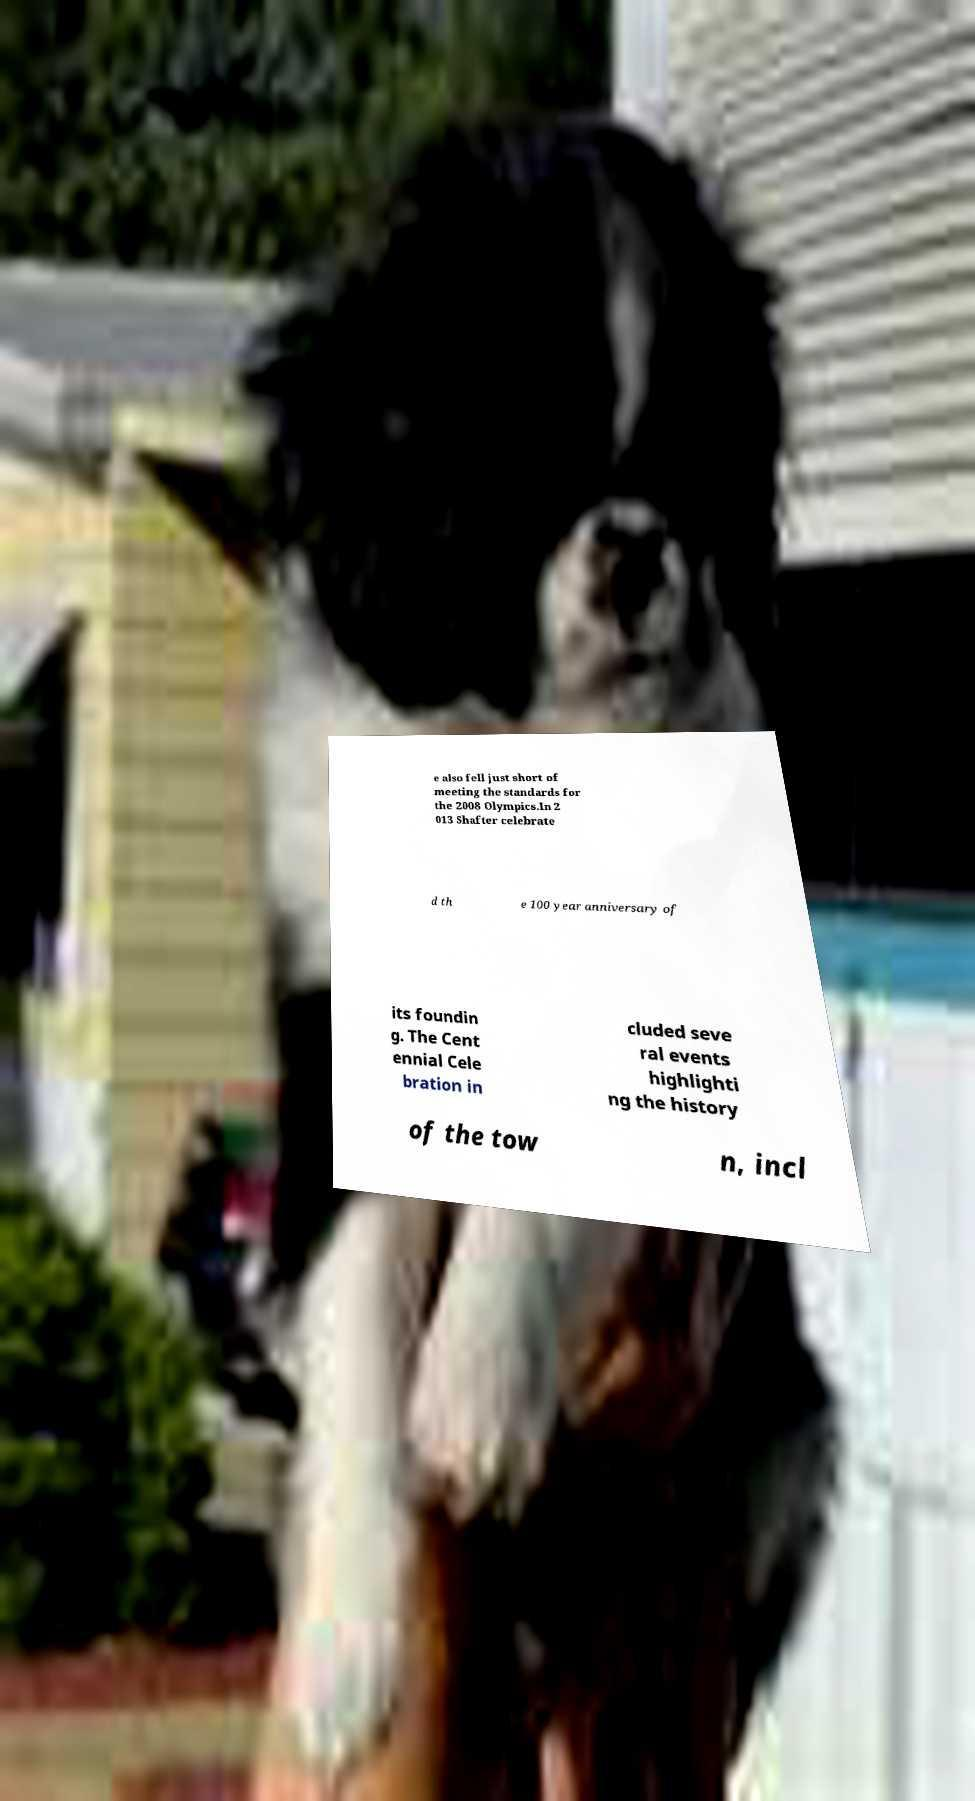Could you assist in decoding the text presented in this image and type it out clearly? e also fell just short of meeting the standards for the 2008 Olympics.In 2 013 Shafter celebrate d th e 100 year anniversary of its foundin g. The Cent ennial Cele bration in cluded seve ral events highlighti ng the history of the tow n, incl 